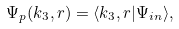Convert formula to latex. <formula><loc_0><loc_0><loc_500><loc_500>\Psi _ { p } ( { k } _ { 3 } , r ) = \langle { k } _ { 3 } , r | \Psi _ { i n } \rangle ,</formula> 